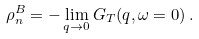Convert formula to latex. <formula><loc_0><loc_0><loc_500><loc_500>\rho _ { n } ^ { B } = - \lim _ { { q } \to 0 } G _ { T } ( { q } , \omega = 0 ) \, .</formula> 